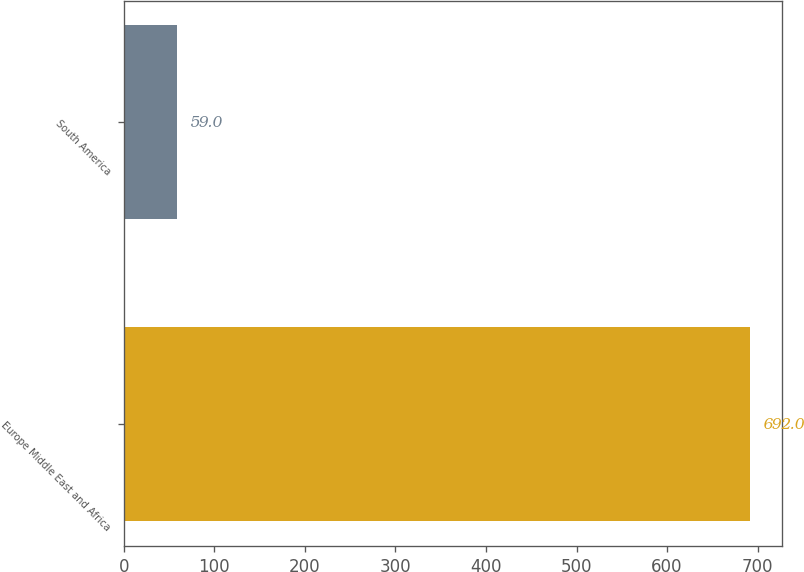<chart> <loc_0><loc_0><loc_500><loc_500><bar_chart><fcel>Europe Middle East and Africa<fcel>South America<nl><fcel>692<fcel>59<nl></chart> 